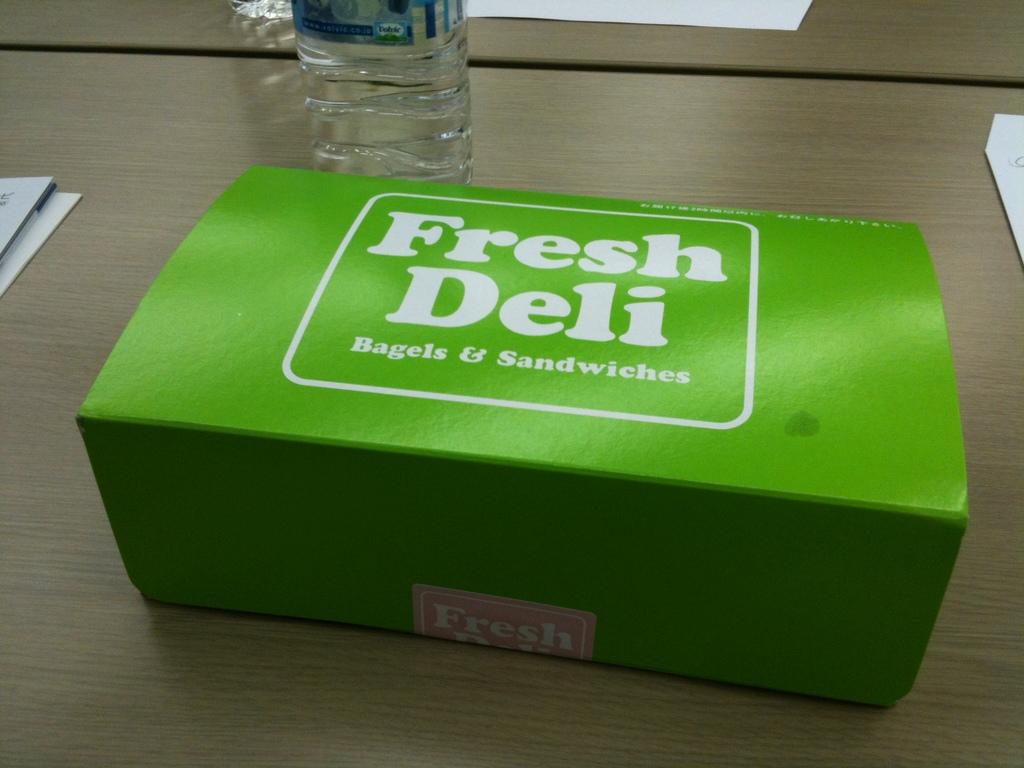What does fresh deli sell?
Give a very brief answer. Bagels & sandwiches. 